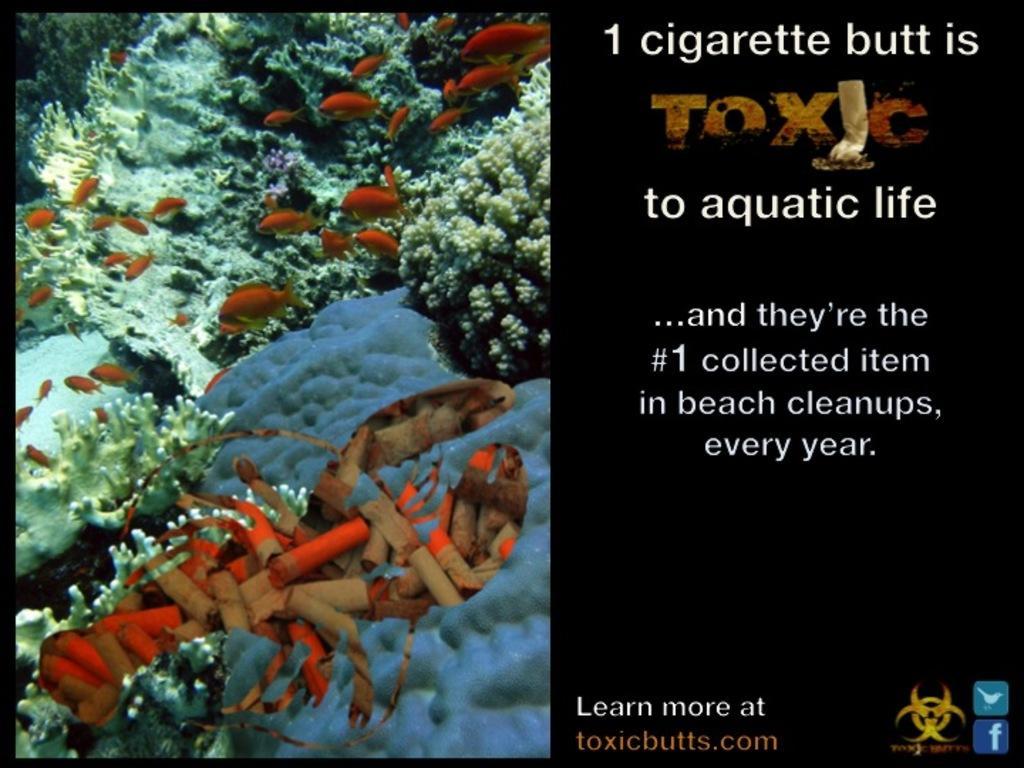Please provide a concise description of this image. This is an edited image. On the left side, we see the fishes are swimming in the water. We even see some aquatic plants and aquatic animals. On the right side, we see some text written in white color. In the background, it is black in color. 